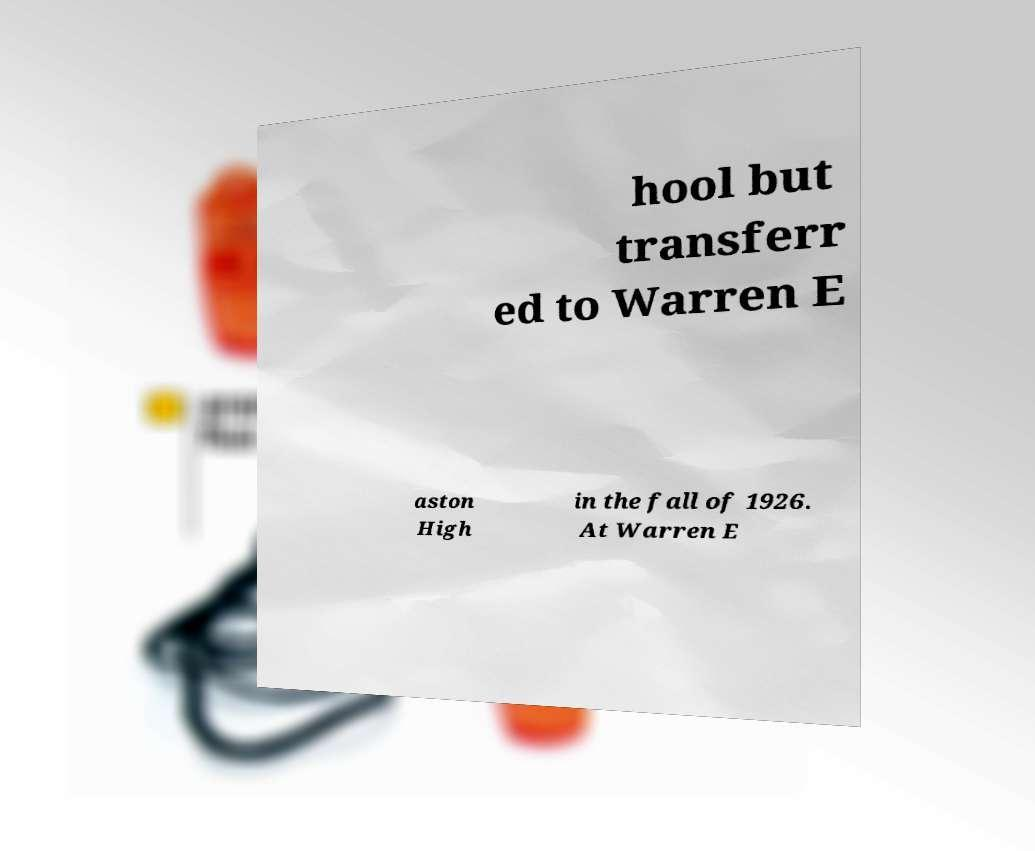Please read and relay the text visible in this image. What does it say? hool but transferr ed to Warren E aston High in the fall of 1926. At Warren E 